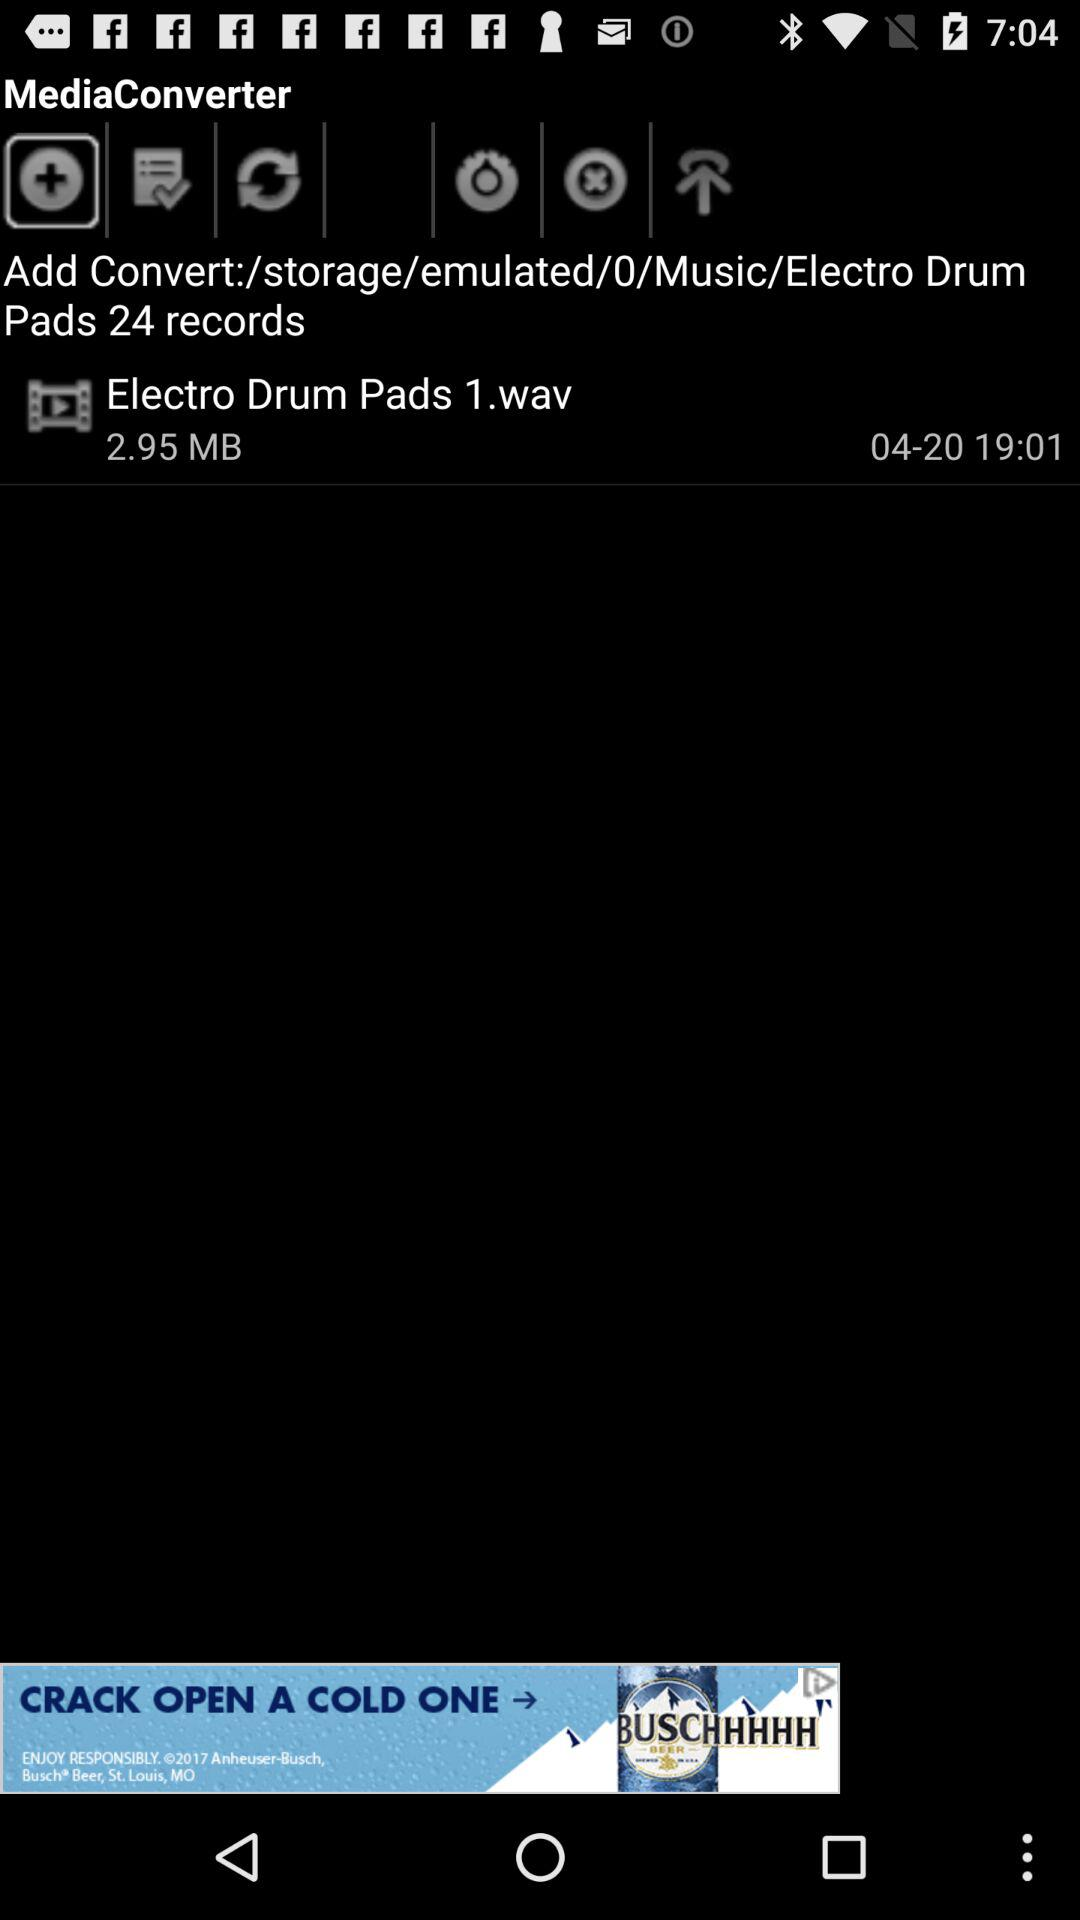How many records have been shown? There are 24 records. 